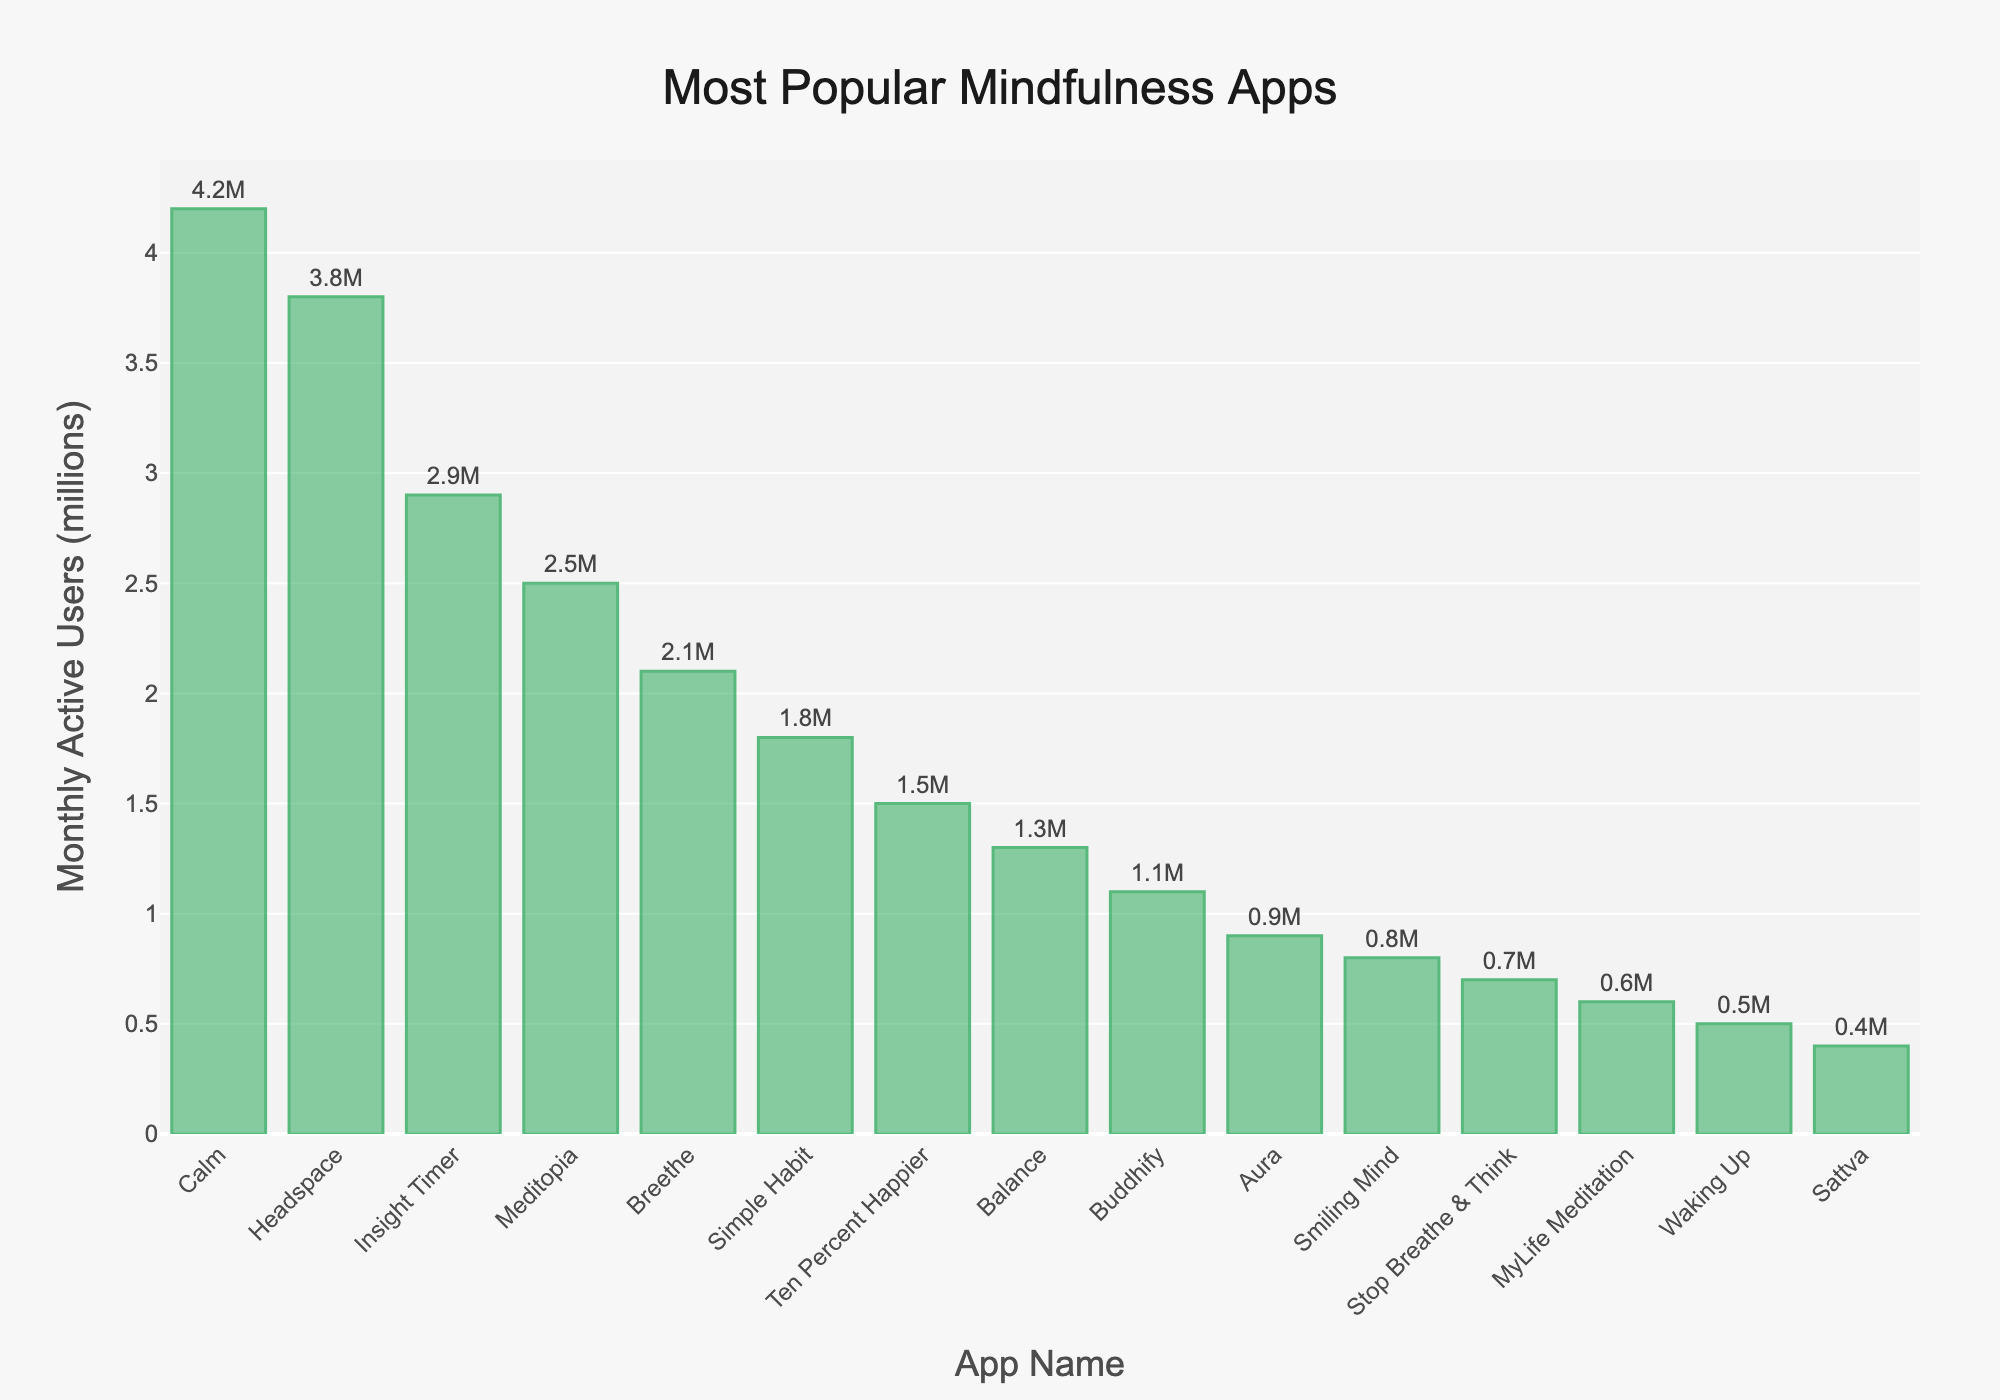What's the total number of active users for the top three apps? To find the total number of active users for the top three apps, sum the monthly active users of Calm (4.2 million), Headspace (3.8 million), and Insight Timer (2.9 million). The sum is 4.2 + 3.8 + 2.9 = 10.9 million.
Answer: 10.9 million Which app has the fewest monthly active users? The app with the fewest monthly active users is Sattva with 0.4 million users. This can be seen at the bottom of the sorted bar chart.
Answer: Sattva How many more active users does Calm have compared to Balance? Calm has 4.2 million active users, and Balance has 1.3 million. The difference is 4.2 - 1.3 = 2.9 million.
Answer: 2.9 million What is the combined user count for the apps with fewer than 2 million users? Sum the monthly active users of Ten Percent Happier (1.5 million), Balance (1.3 million), Buddhify (1.1 million), Aura (0.9 million), Smiling Mind (0.8 million), Stop Breathe & Think (0.7 million), MyLife Meditation (0.6 million), Waking Up (0.5 million), and Sattva (0.4 million). The total is 1.5 + 1.3 + 1.1 + 0.9 + 0.8 + 0.7 + 0.6 + 0.5 + 0.4 = 7.8 million.
Answer: 7.8 million How does the number of active users for Simple Habit compare to Breethe? Simple Habit has 1.8 million active users, and Breethe has 2.1 million. Simple Habit has fewer users compared to Breethe.
Answer: Simple Habit has fewer Which app ranks fifth in terms of monthly active users? The fifth app in terms of monthly active users is Breethe with 2.1 million users, as seen in the sorted bar chart.
Answer: Breethe What is the average number of monthly active users for all the apps in the chart? Sum the monthly active users for all apps and then divide by the number of apps (15). The sum is 4.2 + 3.8 + 2.9 + 2.5 + 2.1 + 1.8 + 1.5 + 1.3 + 1.1 + 0.9 + 0.8 + 0.7 + 0.6 + 0.5 + 0.4 = 25.1 million. The average is 25.1 / 15 ≈ 1.67 million.
Answer: 1.67 million What is the total number of active users for apps with more than 2 million users each? Sum the monthly active users for Calm (4.2 million), Headspace (3.8 million), Insight Timer (2.9 million), Meditopia (2.5 million), and Breethe (2.1 million). The total is 4.2 + 3.8 + 2.9 + 2.5 + 2.1 = 15.5 million.
Answer: 15.5 million Which app has the third-highest number of monthly active users? The third-highest app in terms of monthly active users is Insight Timer with 2.9 million users, as seen in the sorted bar chart.
Answer: Insight Timer 